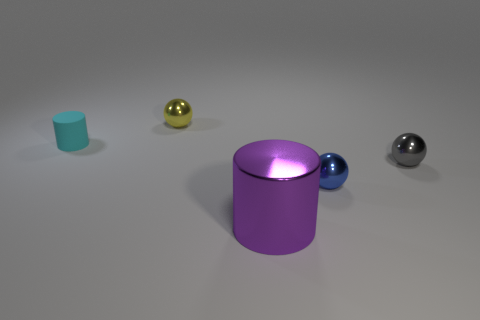Add 2 tiny gray objects. How many objects exist? 7 Subtract all gray metallic spheres. How many spheres are left? 2 Add 4 cyan matte cylinders. How many cyan matte cylinders exist? 5 Subtract 0 green cylinders. How many objects are left? 5 Subtract all spheres. How many objects are left? 2 Subtract all brown spheres. Subtract all brown blocks. How many spheres are left? 3 Subtract all purple metal objects. Subtract all tiny objects. How many objects are left? 0 Add 4 gray balls. How many gray balls are left? 5 